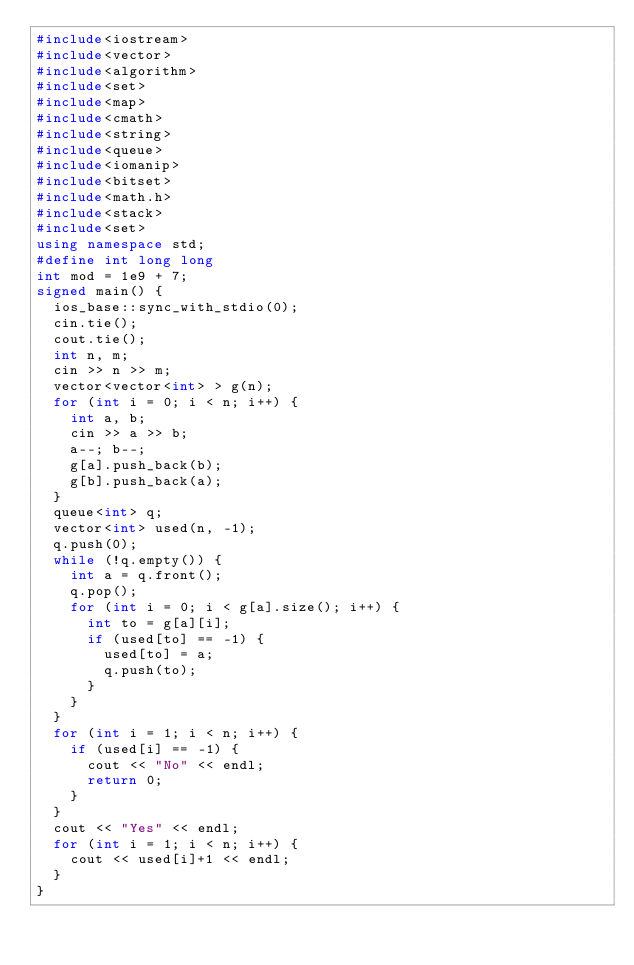<code> <loc_0><loc_0><loc_500><loc_500><_C++_>#include<iostream>
#include<vector>
#include<algorithm>
#include<set>
#include<map>
#include<cmath>
#include<string>
#include<queue>
#include<iomanip>
#include<bitset>
#include<math.h>
#include<stack>
#include<set>
using namespace std;
#define int long long
int mod = 1e9 + 7;
signed main() {
	ios_base::sync_with_stdio(0);
	cin.tie();
	cout.tie();
	int n, m;
	cin >> n >> m;
	vector<vector<int> > g(n);
	for (int i = 0; i < n; i++) {
		int a, b;
		cin >> a >> b;
		a--; b--;
		g[a].push_back(b);
		g[b].push_back(a);
	}
	queue<int> q;
	vector<int> used(n, -1);
	q.push(0);
	while (!q.empty()) {
		int a = q.front();
		q.pop();
		for (int i = 0; i < g[a].size(); i++) {
			int to = g[a][i];
			if (used[to] == -1) {
				used[to] = a;
				q.push(to);
			}
		}
	}
	for (int i = 1; i < n; i++) {
		if (used[i] == -1) {
			cout << "No" << endl;
			return 0;
		}
	}
	cout << "Yes" << endl;
	for (int i = 1; i < n; i++) {
		cout << used[i]+1 << endl;
	}
}
	</code> 